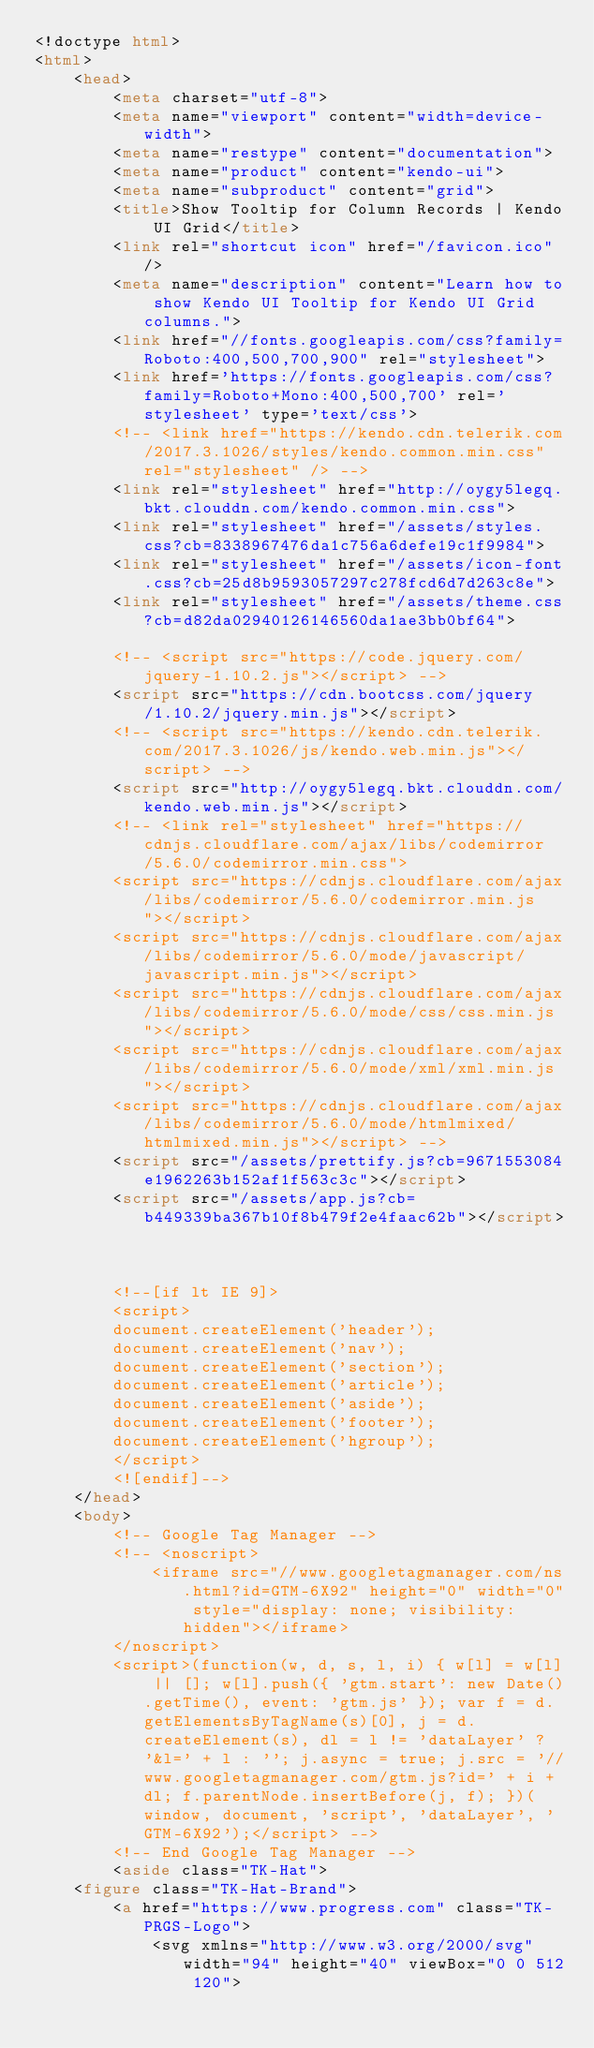Convert code to text. <code><loc_0><loc_0><loc_500><loc_500><_HTML_><!doctype html>
<html>
    <head>
        <meta charset="utf-8">
        <meta name="viewport" content="width=device-width">
        <meta name="restype" content="documentation">
        <meta name="product" content="kendo-ui">
        <meta name="subproduct" content="grid">
        <title>Show Tooltip for Column Records | Kendo UI Grid</title>
        <link rel="shortcut icon" href="/favicon.ico"/>
        <meta name="description" content="Learn how to show Kendo UI Tooltip for Kendo UI Grid columns.">
        <link href="//fonts.googleapis.com/css?family=Roboto:400,500,700,900" rel="stylesheet">
        <link href='https://fonts.googleapis.com/css?family=Roboto+Mono:400,500,700' rel='stylesheet' type='text/css'>
        <!-- <link href="https://kendo.cdn.telerik.com/2017.3.1026/styles/kendo.common.min.css" rel="stylesheet" /> -->
        <link rel="stylesheet" href="http://oygy5legq.bkt.clouddn.com/kendo.common.min.css">
        <link rel="stylesheet" href="/assets/styles.css?cb=8338967476da1c756a6defe19c1f9984">
        <link rel="stylesheet" href="/assets/icon-font.css?cb=25d8b9593057297c278fcd6d7d263c8e">
        <link rel="stylesheet" href="/assets/theme.css?cb=d82da02940126146560da1ae3bb0bf64">
        
        <!-- <script src="https://code.jquery.com/jquery-1.10.2.js"></script> -->
        <script src="https://cdn.bootcss.com/jquery/1.10.2/jquery.min.js"></script>
        <!-- <script src="https://kendo.cdn.telerik.com/2017.3.1026/js/kendo.web.min.js"></script> -->
        <script src="http://oygy5legq.bkt.clouddn.com/kendo.web.min.js"></script>
        <!-- <link rel="stylesheet" href="https://cdnjs.cloudflare.com/ajax/libs/codemirror/5.6.0/codemirror.min.css">
        <script src="https://cdnjs.cloudflare.com/ajax/libs/codemirror/5.6.0/codemirror.min.js"></script>
        <script src="https://cdnjs.cloudflare.com/ajax/libs/codemirror/5.6.0/mode/javascript/javascript.min.js"></script>
        <script src="https://cdnjs.cloudflare.com/ajax/libs/codemirror/5.6.0/mode/css/css.min.js"></script>
        <script src="https://cdnjs.cloudflare.com/ajax/libs/codemirror/5.6.0/mode/xml/xml.min.js"></script>
        <script src="https://cdnjs.cloudflare.com/ajax/libs/codemirror/5.6.0/mode/htmlmixed/htmlmixed.min.js"></script> -->
        <script src="/assets/prettify.js?cb=9671553084e1962263b152af1f563c3c"></script>
        <script src="/assets/app.js?cb=b449339ba367b10f8b479f2e4faac62b"></script>
        
        

        <!--[if lt IE 9]>
        <script>
        document.createElement('header');
        document.createElement('nav');
        document.createElement('section');
        document.createElement('article');
        document.createElement('aside');
        document.createElement('footer');
        document.createElement('hgroup');
        </script>
        <![endif]-->
    </head>
    <body>
        <!-- Google Tag Manager -->
        <!-- <noscript>
            <iframe src="//www.googletagmanager.com/ns.html?id=GTM-6X92" height="0" width="0" style="display: none; visibility: hidden"></iframe>
        </noscript>
        <script>(function(w, d, s, l, i) { w[l] = w[l] || []; w[l].push({ 'gtm.start': new Date().getTime(), event: 'gtm.js' }); var f = d.getElementsByTagName(s)[0], j = d.createElement(s), dl = l != 'dataLayer' ? '&l=' + l : ''; j.async = true; j.src = '//www.googletagmanager.com/gtm.js?id=' + i + dl; f.parentNode.insertBefore(j, f); })(window, document, 'script', 'dataLayer', 'GTM-6X92');</script> -->
        <!-- End Google Tag Manager -->
        <aside class="TK-Hat">
    <figure class="TK-Hat-Brand">
        <a href="https://www.progress.com" class="TK-PRGS-Logo">
            <svg xmlns="http://www.w3.org/2000/svg" width="94" height="40" viewBox="0 0 512 120"></code> 